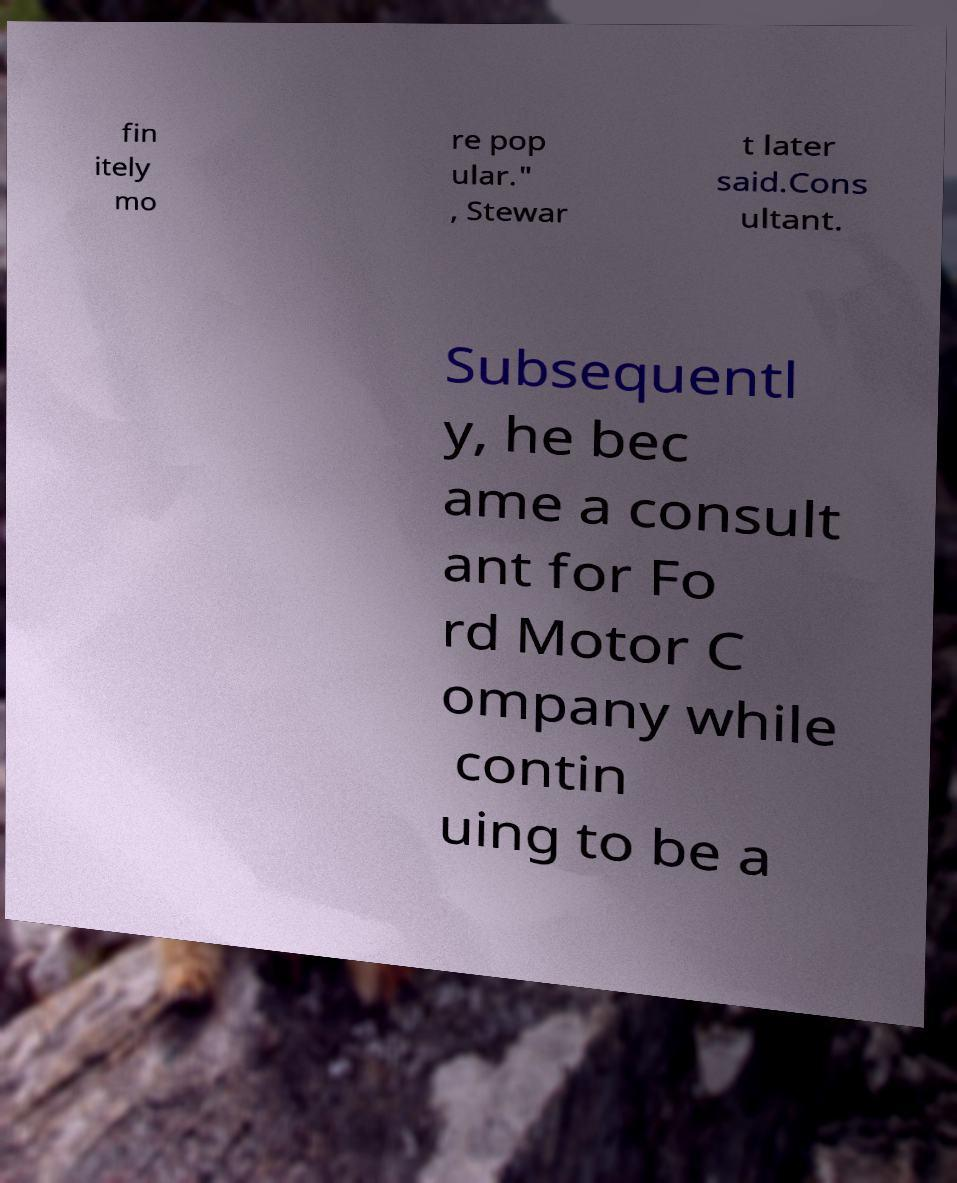Could you extract and type out the text from this image? fin itely mo re pop ular." , Stewar t later said.Cons ultant. Subsequentl y, he bec ame a consult ant for Fo rd Motor C ompany while contin uing to be a 